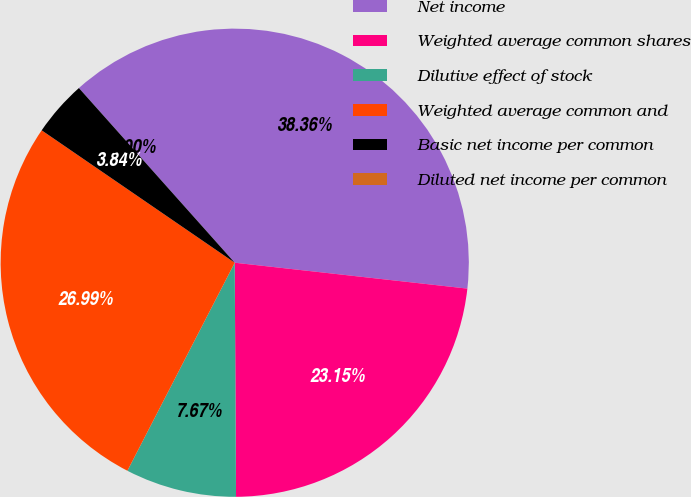<chart> <loc_0><loc_0><loc_500><loc_500><pie_chart><fcel>Net income<fcel>Weighted average common shares<fcel>Dilutive effect of stock<fcel>Weighted average common and<fcel>Basic net income per common<fcel>Diluted net income per common<nl><fcel>38.36%<fcel>23.15%<fcel>7.67%<fcel>26.99%<fcel>3.84%<fcel>0.0%<nl></chart> 